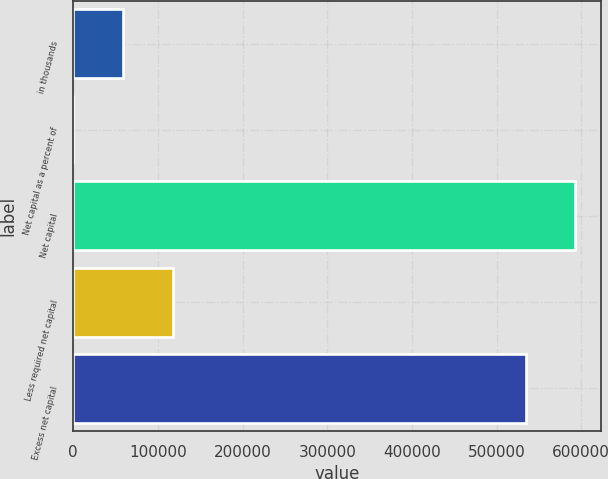Convert chart to OTSL. <chart><loc_0><loc_0><loc_500><loc_500><bar_chart><fcel>in thousands<fcel>Net capital as a percent of<fcel>Net capital<fcel>Less required net capital<fcel>Excess net capital<nl><fcel>58961.2<fcel>21.37<fcel>593196<fcel>117901<fcel>534256<nl></chart> 